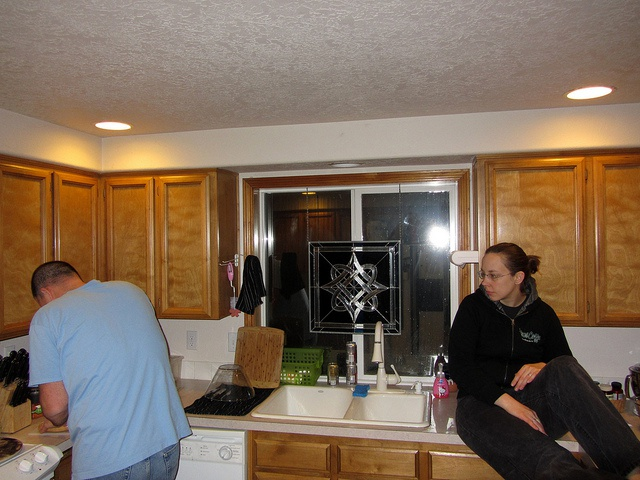Describe the objects in this image and their specific colors. I can see people in gray, black, brown, and maroon tones, people in gray and darkgray tones, sink in gray, darkgray, lightgray, and tan tones, oven in gray, darkgray, and black tones, and bowl in gray, black, and maroon tones in this image. 